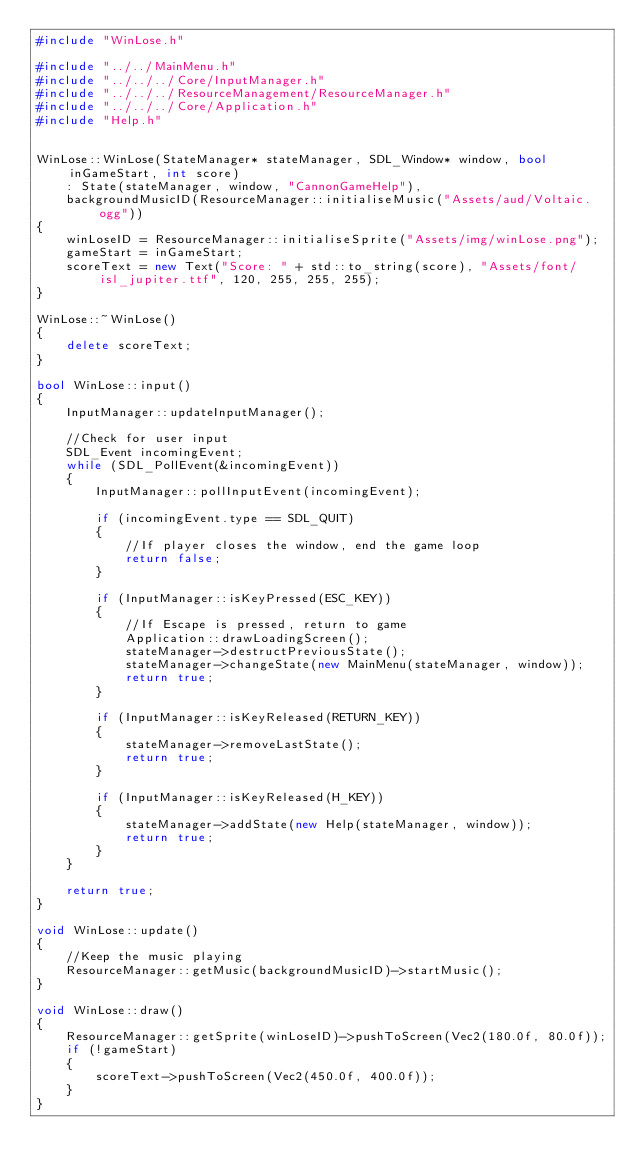Convert code to text. <code><loc_0><loc_0><loc_500><loc_500><_C++_>#include "WinLose.h"

#include "../../MainMenu.h"
#include "../../../Core/InputManager.h"
#include "../../../ResourceManagement/ResourceManager.h"
#include "../../../Core/Application.h"
#include "Help.h"


WinLose::WinLose(StateManager* stateManager, SDL_Window* window, bool inGameStart, int score)
	: State(stateManager, window, "CannonGameHelp"),
	backgroundMusicID(ResourceManager::initialiseMusic("Assets/aud/Voltaic.ogg"))
{
	winLoseID = ResourceManager::initialiseSprite("Assets/img/winLose.png");
	gameStart = inGameStart;
	scoreText = new Text("Score: " + std::to_string(score), "Assets/font/isl_jupiter.ttf", 120, 255, 255, 255);
}

WinLose::~WinLose()
{
	delete scoreText;
}

bool WinLose::input()
{
	InputManager::updateInputManager();

	//Check for user input
	SDL_Event incomingEvent;
	while (SDL_PollEvent(&incomingEvent))
	{
		InputManager::pollInputEvent(incomingEvent);

		if (incomingEvent.type == SDL_QUIT)
		{
			//If player closes the window, end the game loop
			return false;
		}

		if (InputManager::isKeyPressed(ESC_KEY))
		{
			//If Escape is pressed, return to game
			Application::drawLoadingScreen();
			stateManager->destructPreviousState();
			stateManager->changeState(new MainMenu(stateManager, window));
			return true;
		}

		if (InputManager::isKeyReleased(RETURN_KEY))
		{
			stateManager->removeLastState();
			return true;
		}

		if (InputManager::isKeyReleased(H_KEY))
		{
			stateManager->addState(new Help(stateManager, window));
			return true;
		}
	}

	return true;
}

void WinLose::update()
{
	//Keep the music playing
	ResourceManager::getMusic(backgroundMusicID)->startMusic();
}

void WinLose::draw()
{
	ResourceManager::getSprite(winLoseID)->pushToScreen(Vec2(180.0f, 80.0f));
	if (!gameStart)
	{
		scoreText->pushToScreen(Vec2(450.0f, 400.0f));
	}
}</code> 